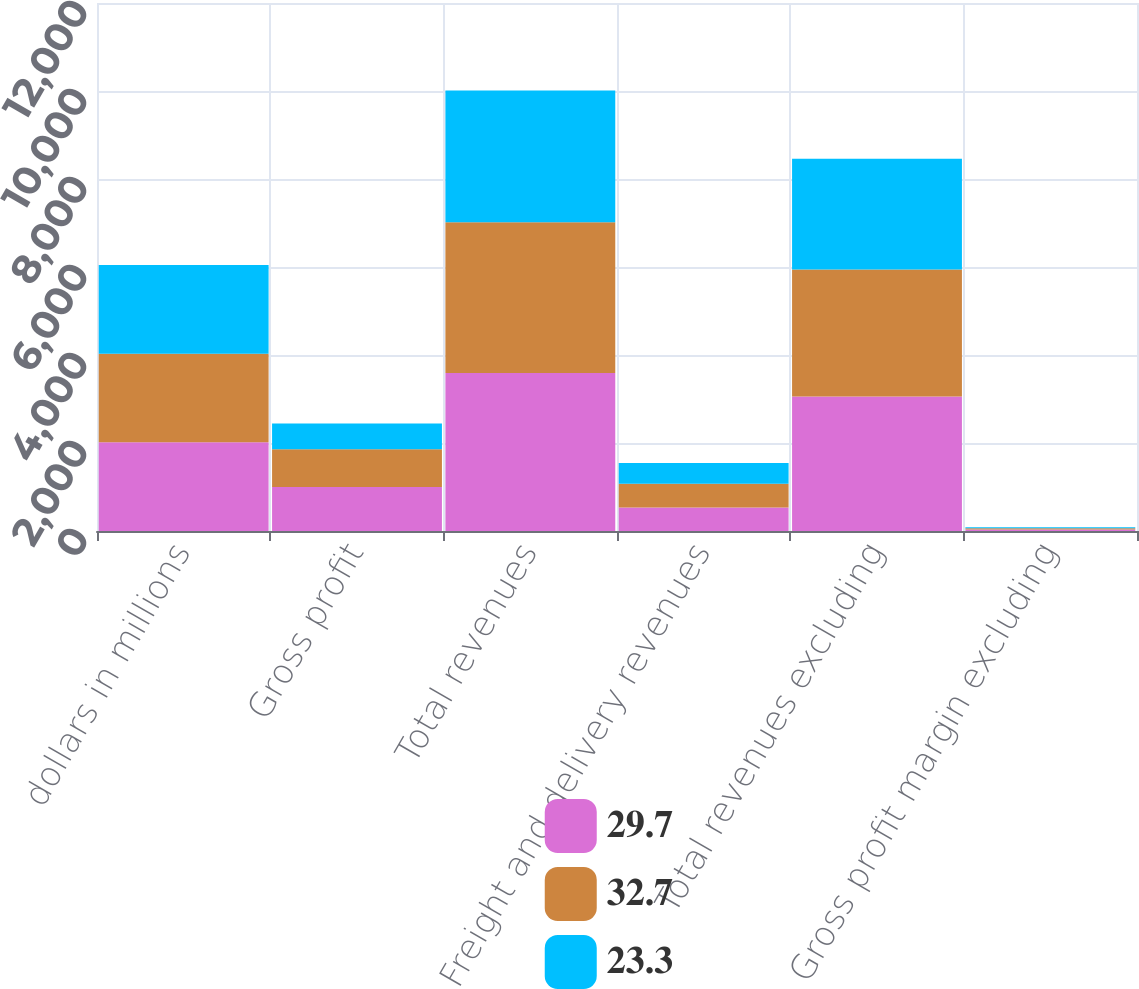<chart> <loc_0><loc_0><loc_500><loc_500><stacked_bar_chart><ecel><fcel>dollars in millions<fcel>Gross profit<fcel>Total revenues<fcel>Freight and delivery revenues<fcel>Total revenues excluding<fcel>Gross profit margin excluding<nl><fcel>29.7<fcel>2016<fcel>1000.8<fcel>3592.7<fcel>536<fcel>3056.7<fcel>32.7<nl><fcel>32.7<fcel>2015<fcel>857.5<fcel>3422.2<fcel>538.1<fcel>2884.1<fcel>29.7<nl><fcel>23.3<fcel>2014<fcel>587.6<fcel>2994.2<fcel>473.1<fcel>2521.1<fcel>23.3<nl></chart> 